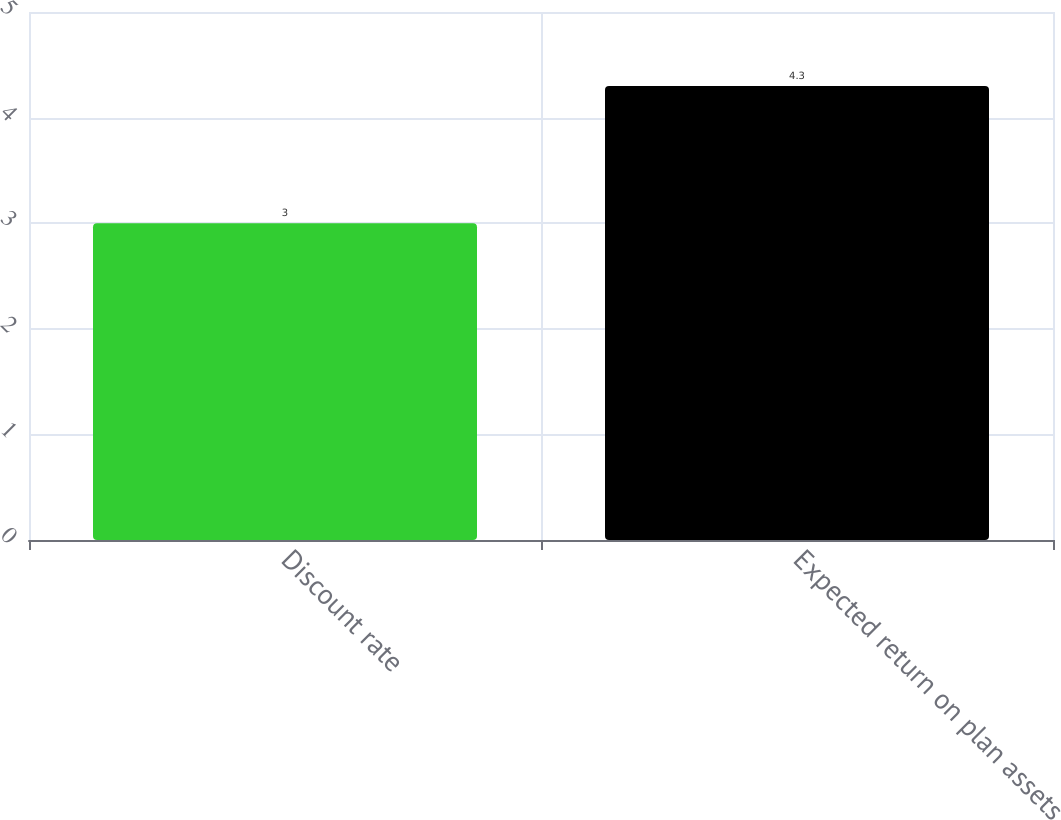Convert chart. <chart><loc_0><loc_0><loc_500><loc_500><bar_chart><fcel>Discount rate<fcel>Expected return on plan assets<nl><fcel>3<fcel>4.3<nl></chart> 